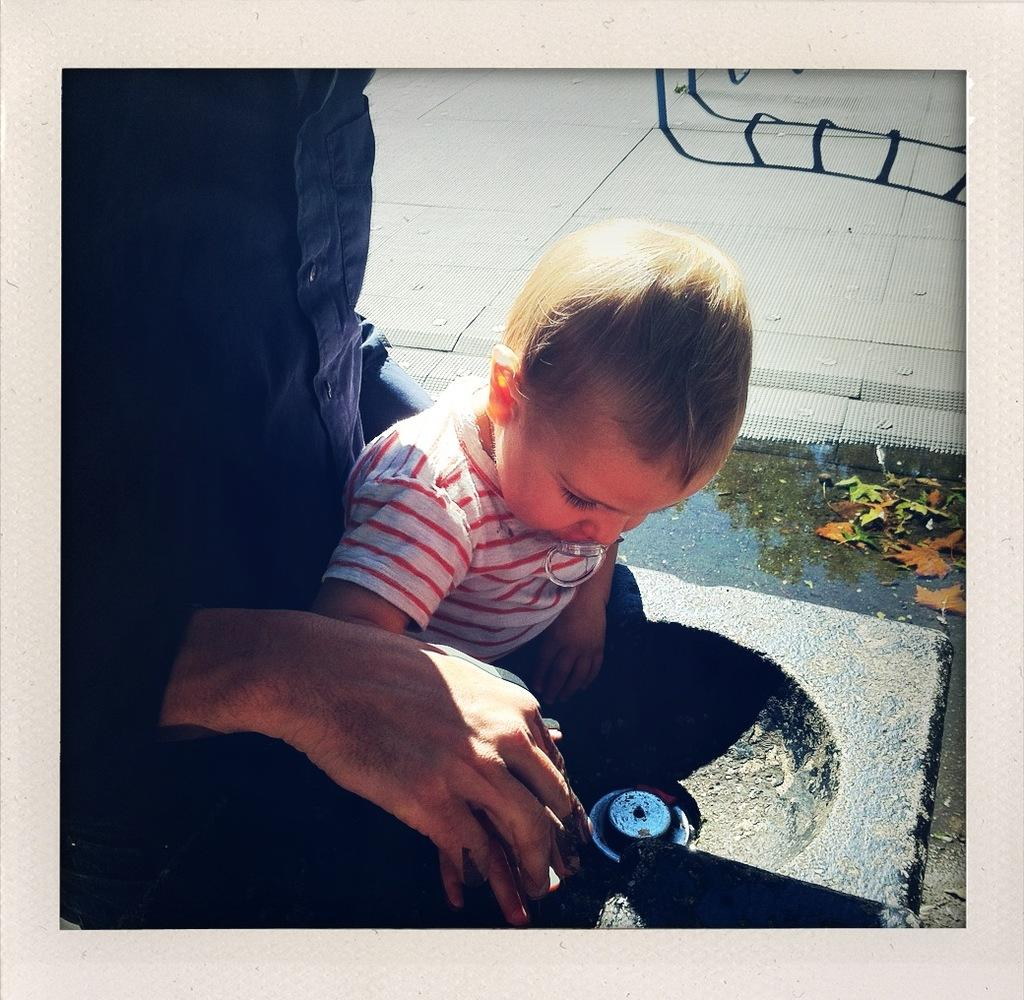How many people are in the image? There are people in the image, but the exact number is not specified. What can be seen beneath the people in the image? The ground is visible in the image. What is present in the water in the image? There are leaves in the water in the image. What is located in the top right corner of the image? There is an object in the top right corner of the image. What type of bell can be heard ringing in the image? There is no bell present in the image, and therefore no sound can be heard. 